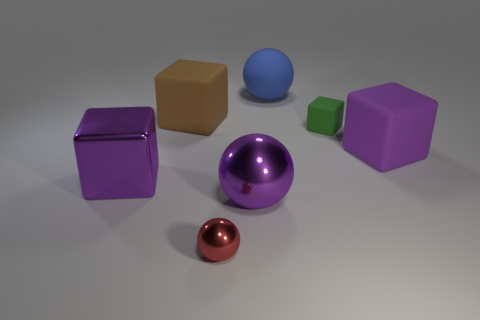Subtract all metallic balls. How many balls are left? 1 Add 1 large purple matte balls. How many objects exist? 8 Subtract all brown blocks. How many blocks are left? 3 Subtract all balls. How many objects are left? 4 Add 4 metal blocks. How many metal blocks are left? 5 Add 3 brown blocks. How many brown blocks exist? 4 Subtract 0 yellow blocks. How many objects are left? 7 Subtract 2 cubes. How many cubes are left? 2 Subtract all purple cubes. Subtract all yellow cylinders. How many cubes are left? 2 Subtract all blue cubes. How many blue spheres are left? 1 